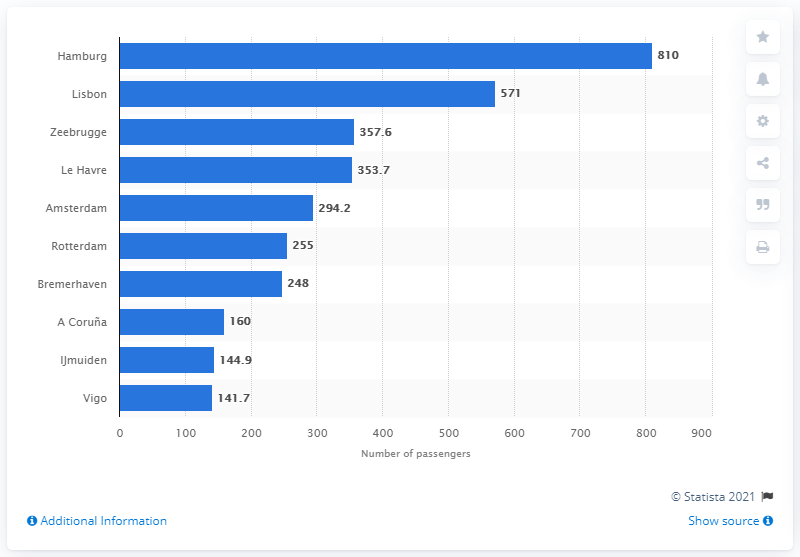Identify some key points in this picture. According to data from 2019, the port in Northern Germany with the most cruise passengers in Atlantic Europe was Hamburg. 